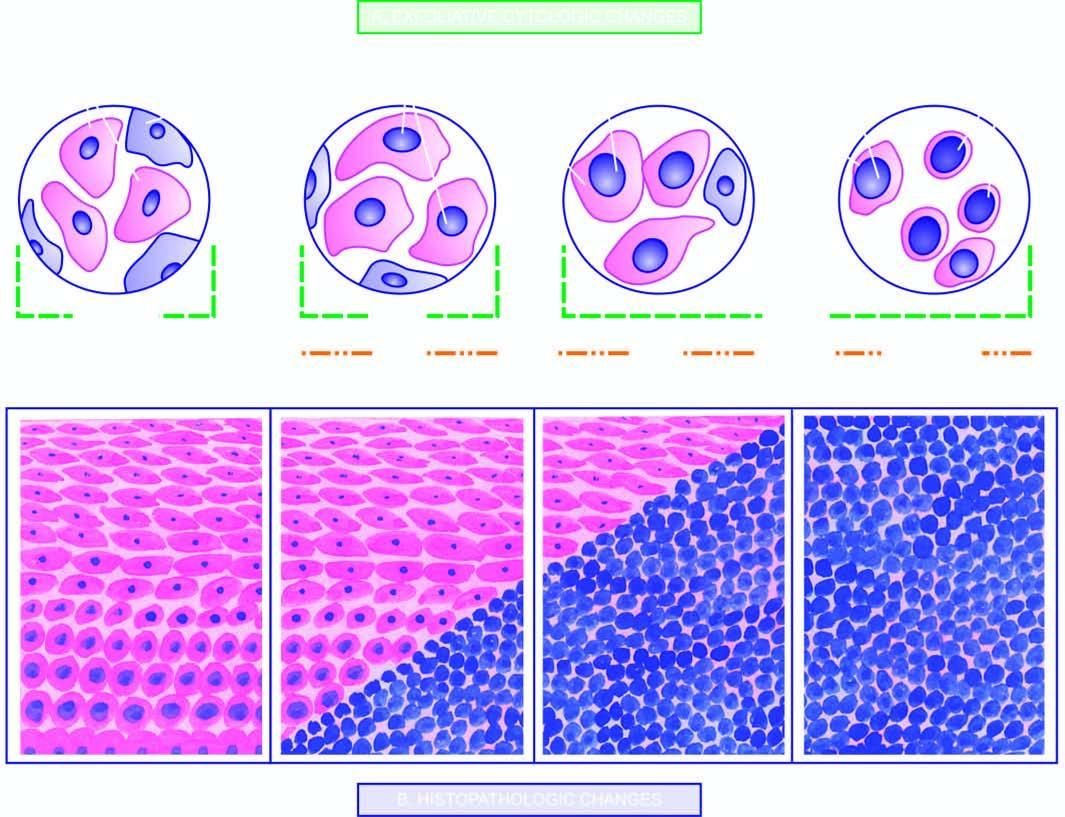s ziehl-neelsen or afb parallel to the increasing severity of grades?
Answer the question using a single word or phrase. No 